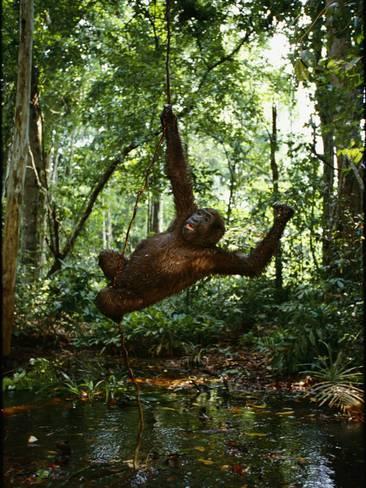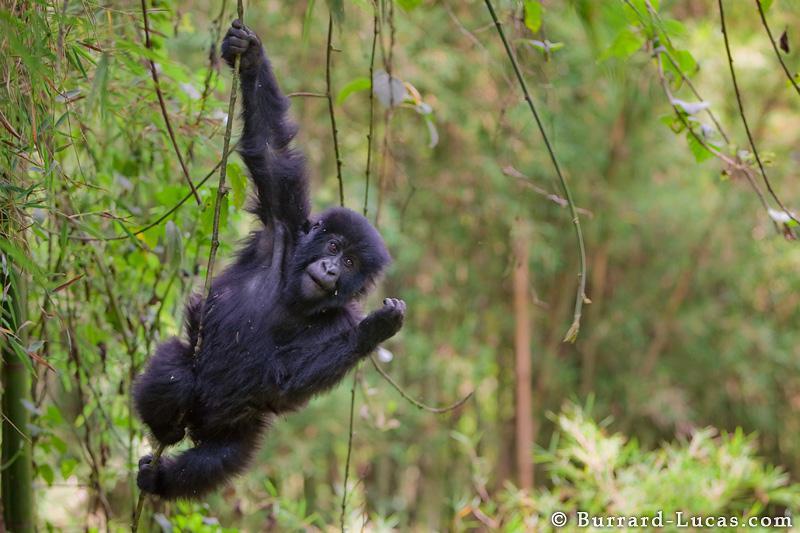The first image is the image on the left, the second image is the image on the right. For the images shown, is this caption "Each image contains just one ape, and each ape is hanging from a branch-like growth." true? Answer yes or no. Yes. The first image is the image on the left, the second image is the image on the right. For the images shown, is this caption "At least one ape is on the ground." true? Answer yes or no. No. 